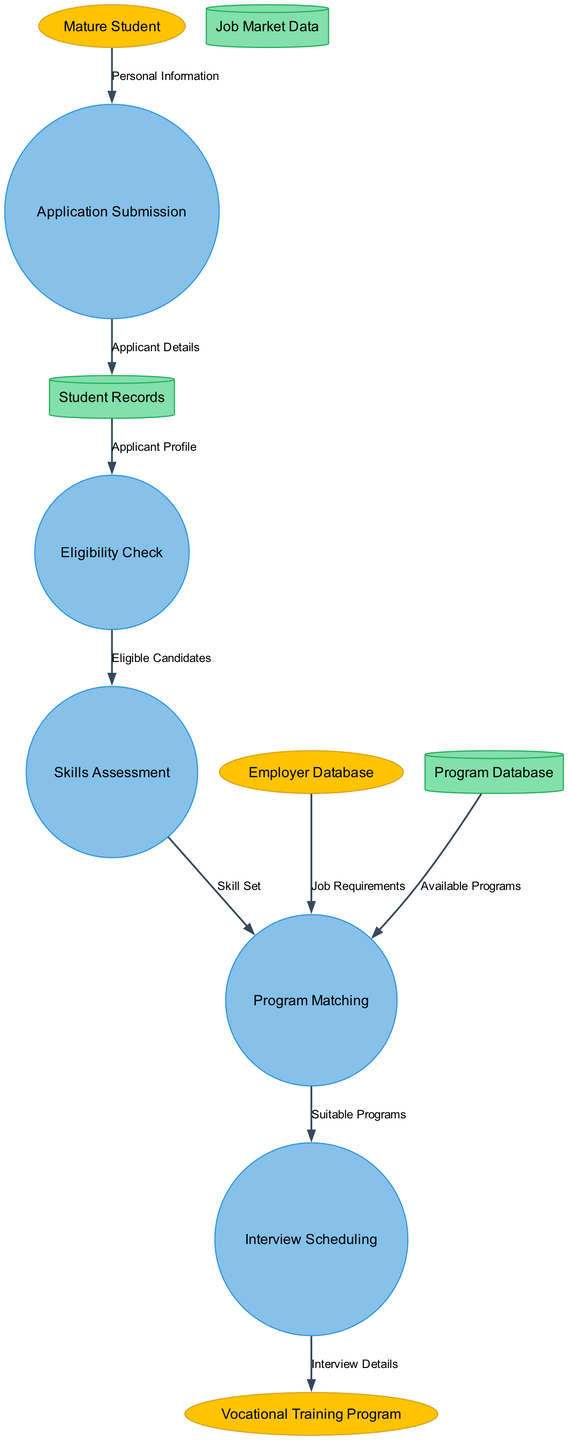What external entities are involved in the diagram? The diagram identifies three external entities: Mature Student, Vocational Training Program, and Employer Database. Each entity is depicted as an ellipse, showing their roles in the data flow process.
Answer: Mature Student, Vocational Training Program, Employer Database How many processes are defined in the diagram? The diagram has a total of five processes illustrated as circles. These processes include Application Submission, Eligibility Check, Skills Assessment, Program Matching, and Interview Scheduling.
Answer: Five What data flow occurs from the Application Submission process to the Student Records data store? The Application Submission process sends Applicant Details to the Student Records data store. This is a direct flow of information that connects these two components in the diagram.
Answer: Applicant Details Which process follows the Eligibility Check process? After the Eligibility Check process, the Skills Assessment process takes place. This indicates that the candidates deemed eligible are then assessed for their skills.
Answer: Skills Assessment What information does the Program Matching process require from the Employer Database? The Program Matching process requires Job Requirements from the Employer Database. This data is essential for aligning candidates' skills with job needs.
Answer: Job Requirements How many data flows are represented in the diagram? There are a total of eight data flows depicted in the diagram, each connecting various nodes and illustrating the transfer of information in the process.
Answer: Eight What is the main purpose of the Interview Scheduling process? The Interview Scheduling process is designed to handle Suitable Programs that match candidates with potential employers so that interviews can be organized for them.
Answer: Suitable Programs Which data store provides information to the Program Matching process? The Program Matching process receives information from the Program Database, which contains Available Programs that candidates can be matched with based on their skills.
Answer: Available Programs 